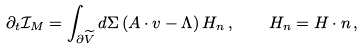Convert formula to latex. <formula><loc_0><loc_0><loc_500><loc_500>\partial _ { t } \mathcal { I } _ { M } = \int _ { \partial \widetilde { V } } d \Sigma \left ( A \cdot v - \Lambda \right ) H _ { n } \, , \quad H _ { n } = H \cdot n \, ,</formula> 